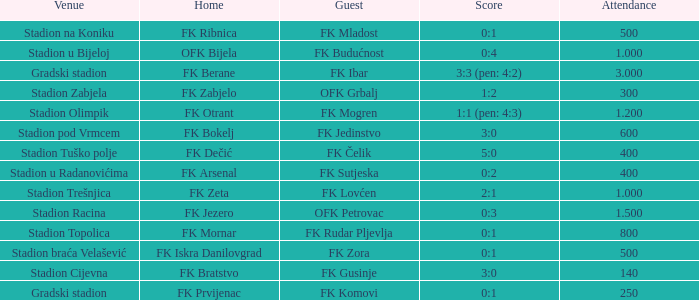What was the attendance of the game that had an away team of FK Mogren? 1.2. 